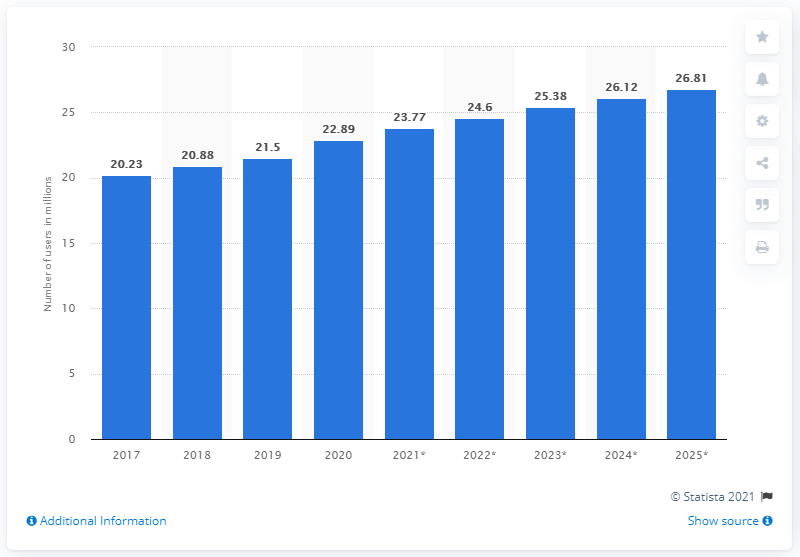Identify some key points in this picture. In 2020, the number of Facebook users in South Africa was 22.89. It is estimated that the number of Facebook users in South Africa will reach 26.81 million in 2025. 